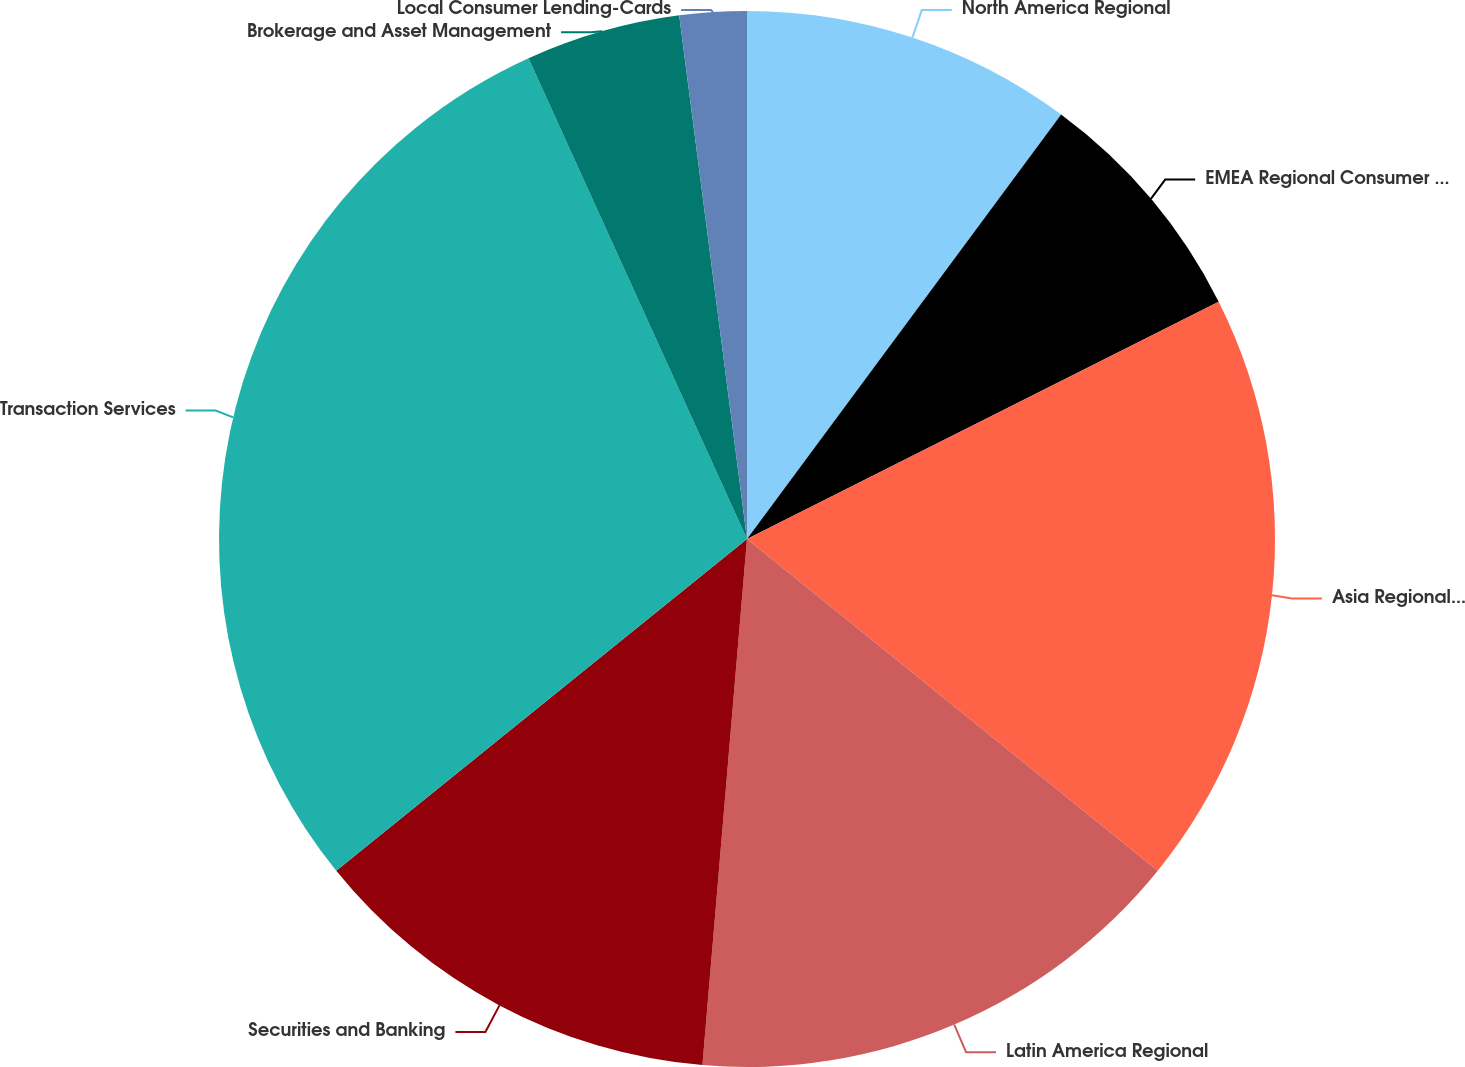Convert chart. <chart><loc_0><loc_0><loc_500><loc_500><pie_chart><fcel>North America Regional<fcel>EMEA Regional Consumer Banking<fcel>Asia Regional Consumer Banking<fcel>Latin America Regional<fcel>Securities and Banking<fcel>Transaction Services<fcel>Brokerage and Asset Management<fcel>Local Consumer Lending-Cards<nl><fcel>10.14%<fcel>7.44%<fcel>18.23%<fcel>15.53%<fcel>12.84%<fcel>29.02%<fcel>4.74%<fcel>2.05%<nl></chart> 